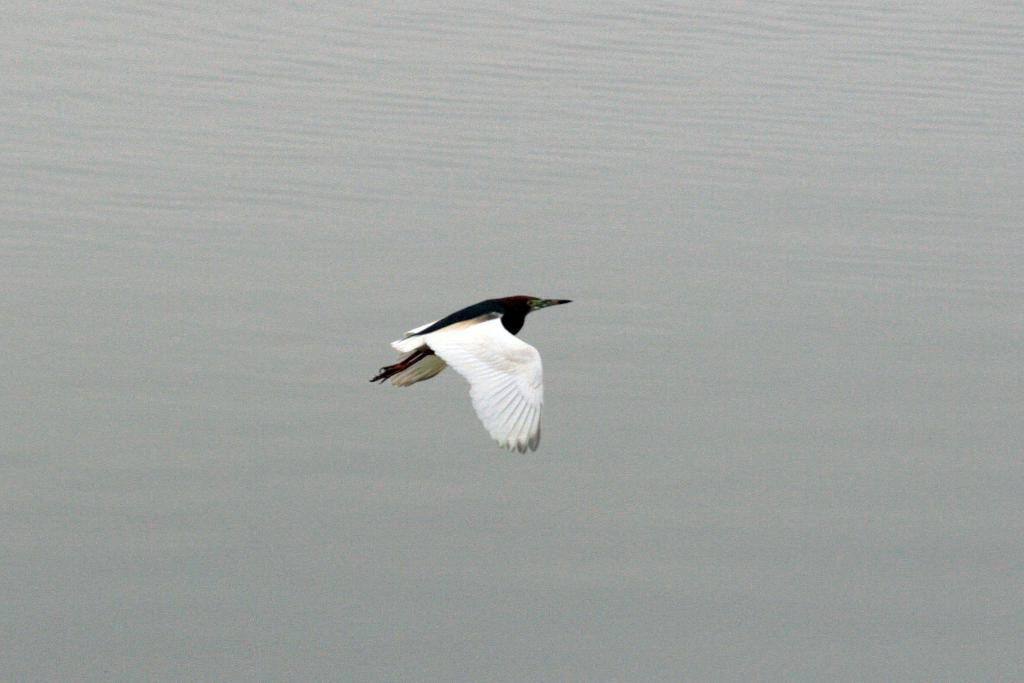What animal can be seen in the image? There is a bird in the image. What is the bird doing in the image? The bird is flying. What can be seen in the background of the image? There is water visible in the background of the image. What country is the bird flying over in the image? The image does not provide any information about the country or location where the bird is flying. 